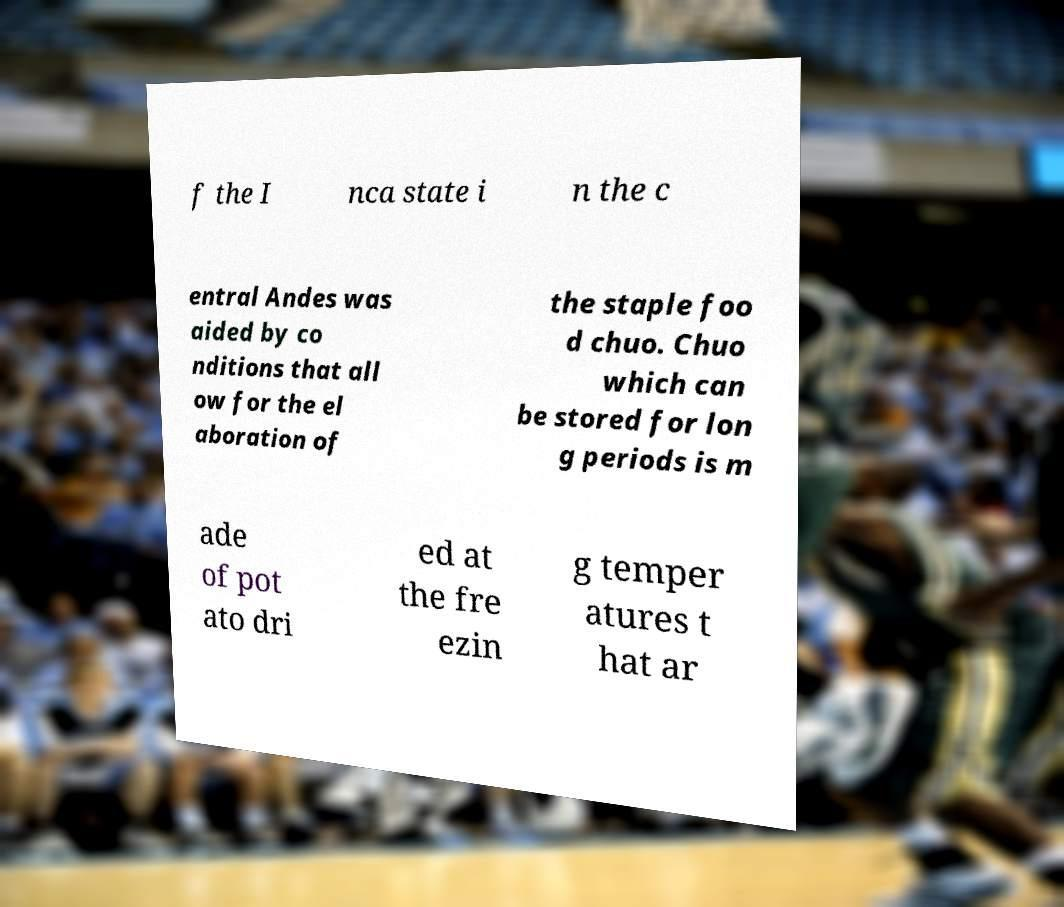Could you assist in decoding the text presented in this image and type it out clearly? f the I nca state i n the c entral Andes was aided by co nditions that all ow for the el aboration of the staple foo d chuo. Chuo which can be stored for lon g periods is m ade of pot ato dri ed at the fre ezin g temper atures t hat ar 